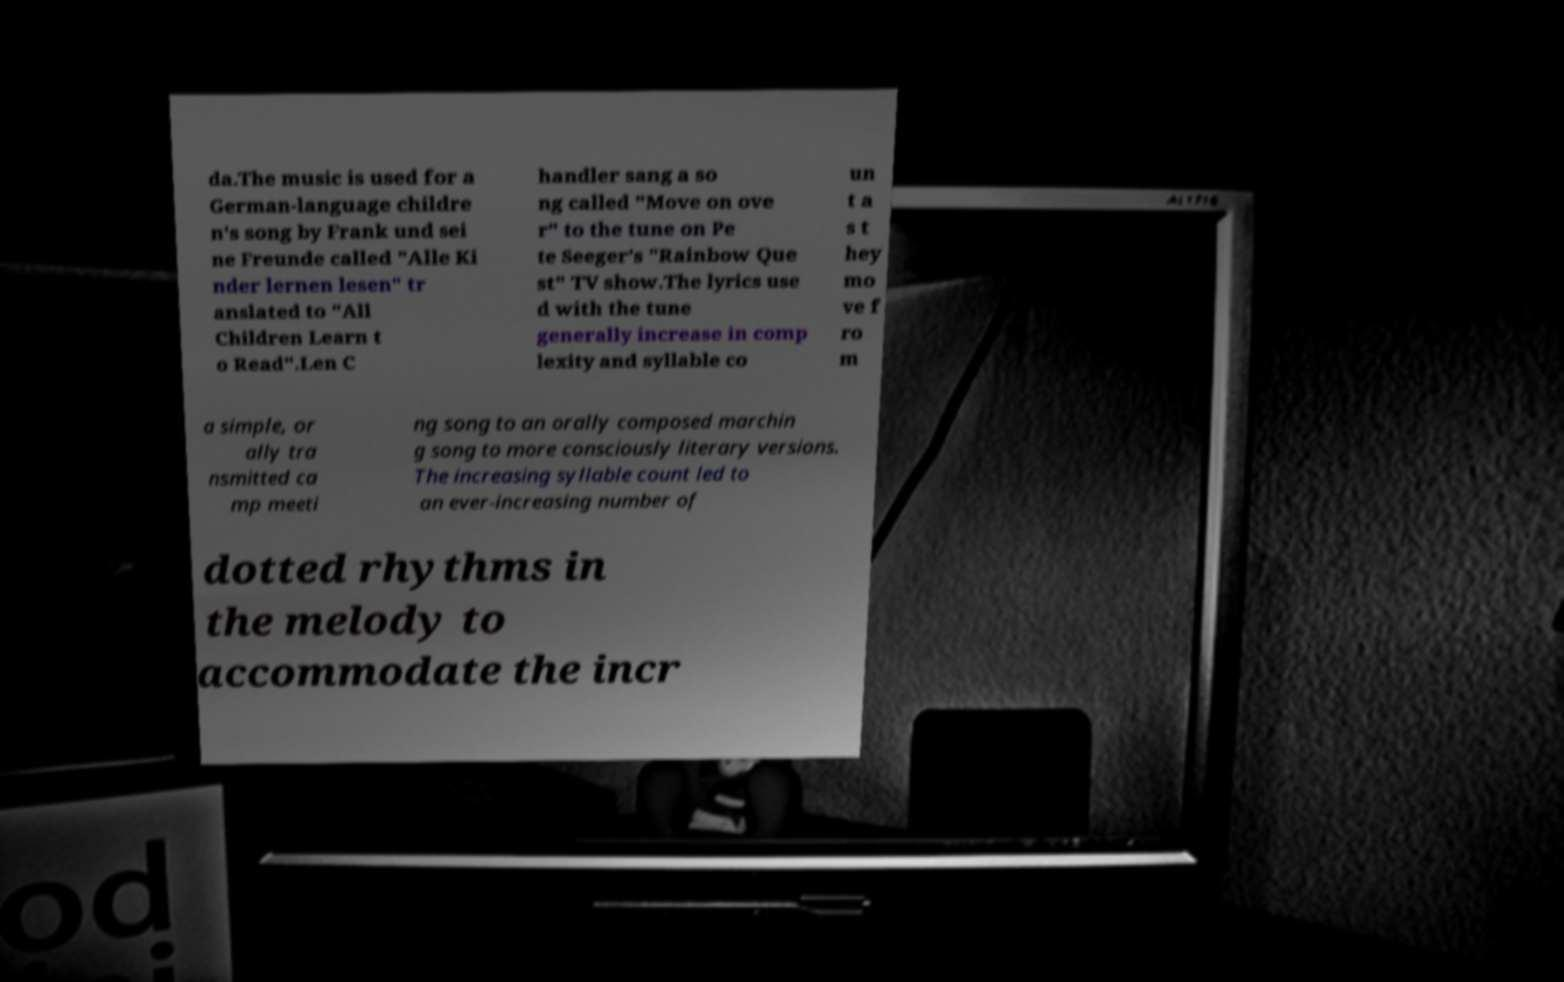I need the written content from this picture converted into text. Can you do that? da.The music is used for a German-language childre n's song by Frank und sei ne Freunde called "Alle Ki nder lernen lesen" tr anslated to "All Children Learn t o Read".Len C handler sang a so ng called "Move on ove r" to the tune on Pe te Seeger's "Rainbow Que st" TV show.The lyrics use d with the tune generally increase in comp lexity and syllable co un t a s t hey mo ve f ro m a simple, or ally tra nsmitted ca mp meeti ng song to an orally composed marchin g song to more consciously literary versions. The increasing syllable count led to an ever-increasing number of dotted rhythms in the melody to accommodate the incr 